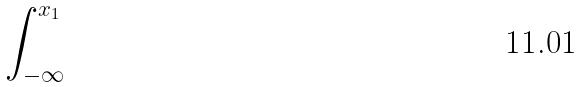<formula> <loc_0><loc_0><loc_500><loc_500>\int _ { - \infty } ^ { x _ { 1 } }</formula> 